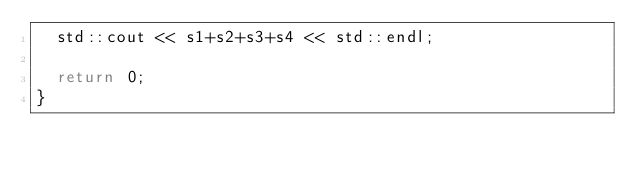Convert code to text. <code><loc_0><loc_0><loc_500><loc_500><_C++_>  std::cout << s1+s2+s3+s4 << std::endl;
  
  return 0;
}
</code> 